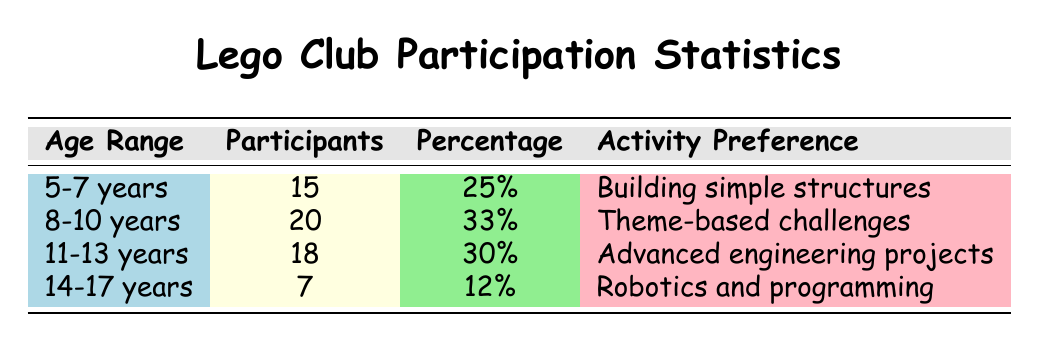What is the age range with the most participants? The table shows the number of participants in each age group. The age range with the highest number of participants is 8-10 years, which has 20 participants.
Answer: 8-10 years How many participants are there in the age group 11-13 years? The table lists the number of participants for each age group, and for the age range 11-13 years, it shows 18 participants.
Answer: 18 What percentage of participants are aged 5-7 years? According to the table, the age range 5-7 years has 25% of participants.
Answer: 25% Is the activity preference for the age range 14-17 years focused on building structures? The table indicates that the activity preference for the age range 14-17 years is robotics and programming, which is not focused on building structures.
Answer: No What is the total number of participants in the Lego club across all age groups? To find the total, we add the number of participants from each age group: 15 (5-7 years) + 20 (8-10 years) + 18 (11-13 years) + 7 (14-17 years) = 60 participants in total.
Answer: 60 What percentage of participants prefer advanced engineering projects? The age range 11-13 years, which corresponds to "advanced engineering projects," has 30% of the total participants in the Lego club.
Answer: 30% How many more participants are there in the 8-10 years group compared to the 14-17 years group? The 8-10 years group has 20 participants, and the 14-17 years group has 7 participants. The difference is 20 - 7 = 13 participants more in the 8-10 years group.
Answer: 13 What age range has the least number of participants? By reviewing the table, the 14-17 years age range has the least number of participants, with only 7 participants compared to other age groups.
Answer: 14-17 years Are there more participants aged 8-10 years than those aged 11-13 years? The table shows that there are 20 participants aged 8-10 years and 18 participants aged 11-13 years. Since 20 is greater than 18, the answer is yes.
Answer: Yes 